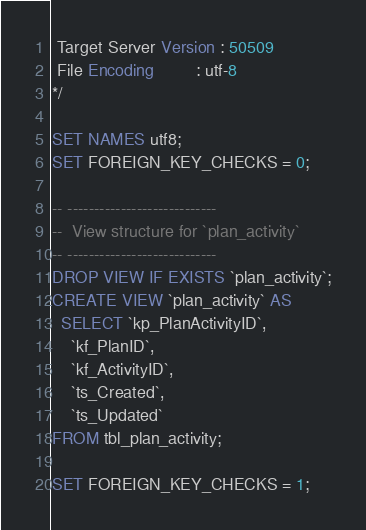<code> <loc_0><loc_0><loc_500><loc_500><_SQL_> Target Server Version : 50509
 File Encoding         : utf-8
*/

SET NAMES utf8;
SET FOREIGN_KEY_CHECKS = 0;

-- ----------------------------
--  View structure for `plan_activity`
-- ----------------------------
DROP VIEW IF EXISTS `plan_activity`;
CREATE VIEW `plan_activity` AS 
  SELECT `kp_PlanActivityID`,
    `kf_PlanID`,
	`kf_ActivityID`,
	`ts_Created`,
	`ts_Updated`
FROM tbl_plan_activity;

SET FOREIGN_KEY_CHECKS = 1;</code> 